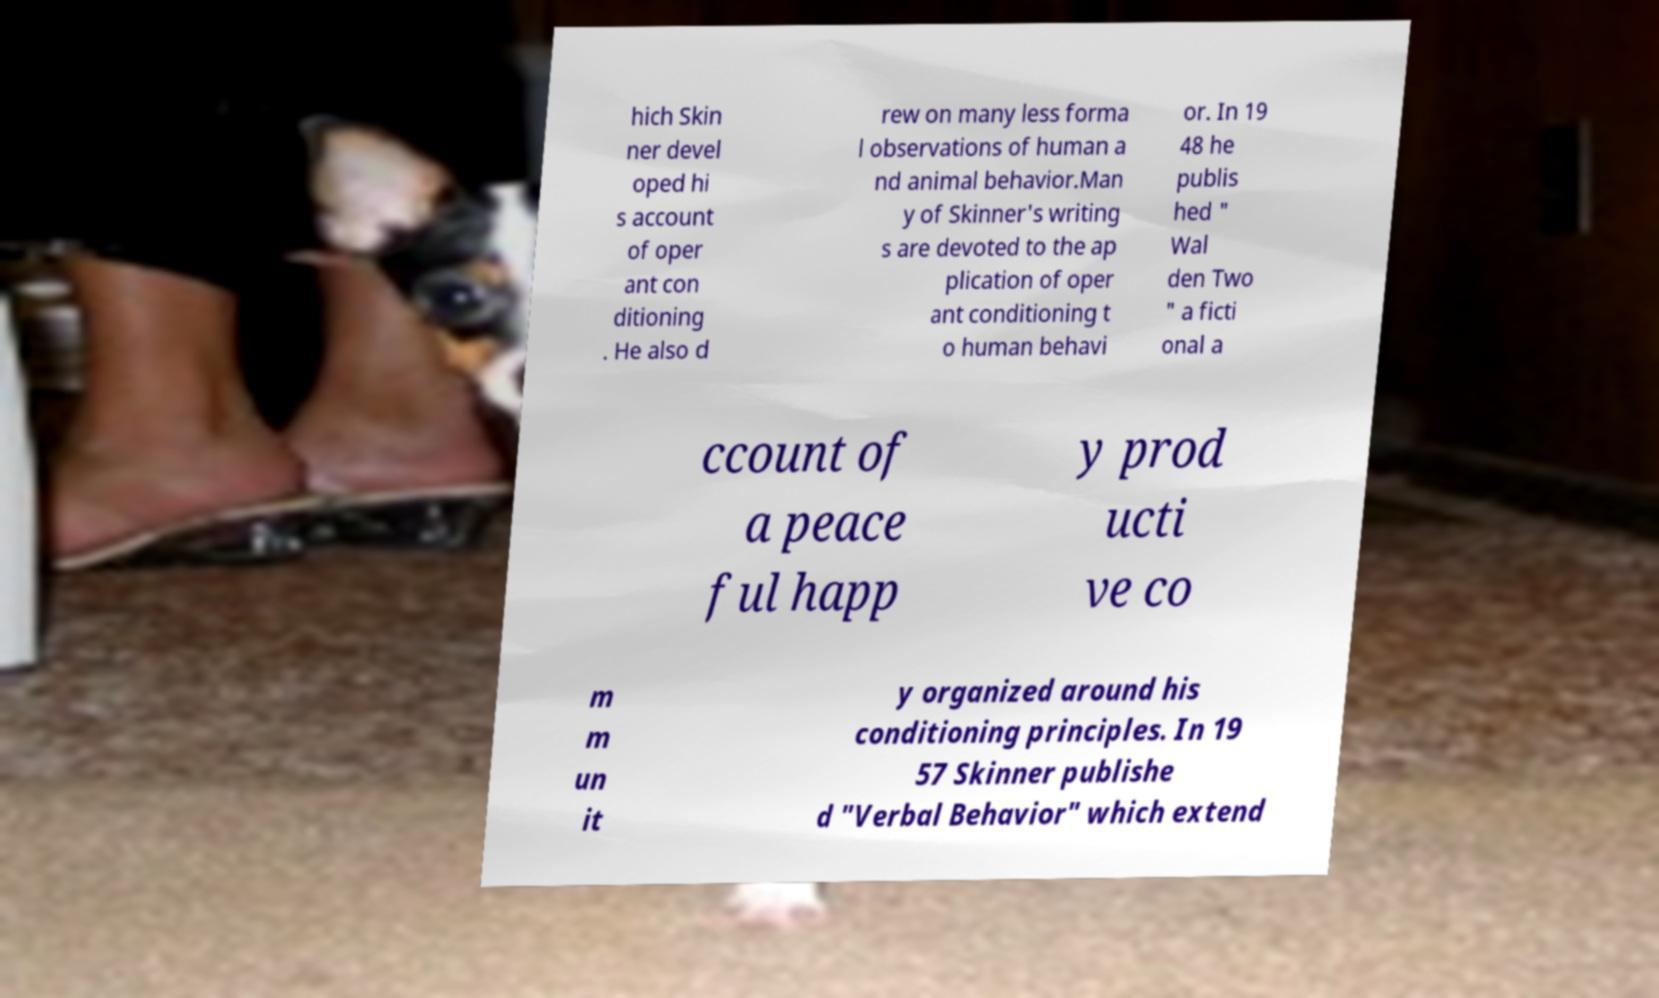Could you assist in decoding the text presented in this image and type it out clearly? hich Skin ner devel oped hi s account of oper ant con ditioning . He also d rew on many less forma l observations of human a nd animal behavior.Man y of Skinner's writing s are devoted to the ap plication of oper ant conditioning t o human behavi or. In 19 48 he publis hed " Wal den Two " a ficti onal a ccount of a peace ful happ y prod ucti ve co m m un it y organized around his conditioning principles. In 19 57 Skinner publishe d "Verbal Behavior" which extend 